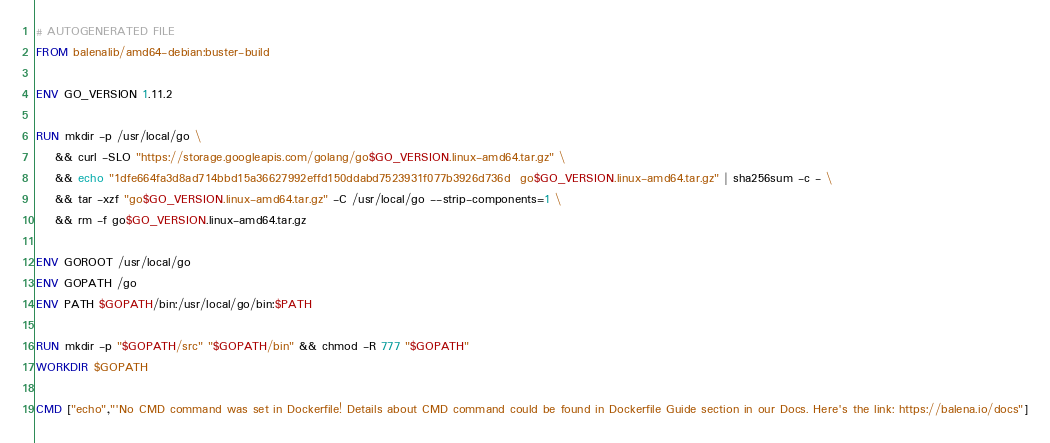Convert code to text. <code><loc_0><loc_0><loc_500><loc_500><_Dockerfile_># AUTOGENERATED FILE
FROM balenalib/amd64-debian:buster-build

ENV GO_VERSION 1.11.2

RUN mkdir -p /usr/local/go \
	&& curl -SLO "https://storage.googleapis.com/golang/go$GO_VERSION.linux-amd64.tar.gz" \
	&& echo "1dfe664fa3d8ad714bbd15a36627992effd150ddabd7523931f077b3926d736d  go$GO_VERSION.linux-amd64.tar.gz" | sha256sum -c - \
	&& tar -xzf "go$GO_VERSION.linux-amd64.tar.gz" -C /usr/local/go --strip-components=1 \
	&& rm -f go$GO_VERSION.linux-amd64.tar.gz

ENV GOROOT /usr/local/go
ENV GOPATH /go
ENV PATH $GOPATH/bin:/usr/local/go/bin:$PATH

RUN mkdir -p "$GOPATH/src" "$GOPATH/bin" && chmod -R 777 "$GOPATH"
WORKDIR $GOPATH

CMD ["echo","'No CMD command was set in Dockerfile! Details about CMD command could be found in Dockerfile Guide section in our Docs. Here's the link: https://balena.io/docs"]</code> 